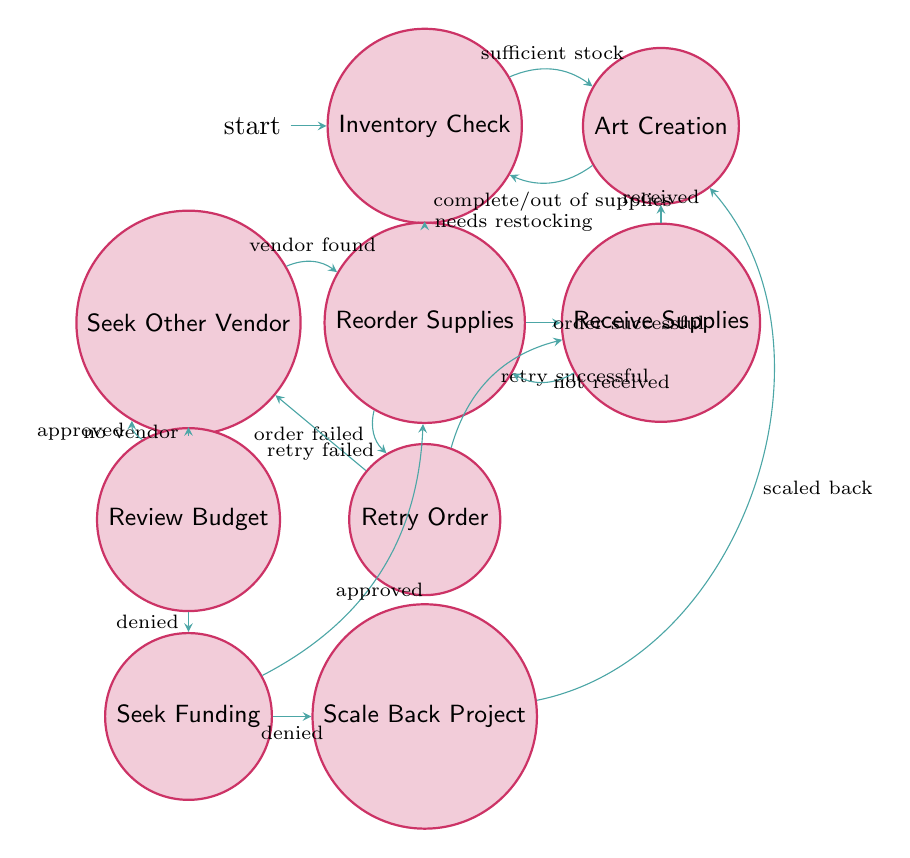What is the initial state of this Finite State Machine? The initial state is represented in the diagram by the starting point, which is labeled "Inventory Check."
Answer: Inventory Check How many states are there in total? To find the total number of states, I count each unique state node in the diagram. There are 10 distinct states: Inventory Check, Art Creation, Reorder Supplies, Receive Supplies, Retry Order, Seek Other Vendor, Review Budget, Seek Funding, Scale Back Project, and Record Broken Supply.
Answer: 10 Which state follows "Receive Supplies" when supplies are received? Following the "Receive Supplies" state, if the supplies are received, the transition leads directly to "Art Creation."
Answer: Art Creation What happens if an order for supplies fails? In the event of a failed order for supplies, the transition takes the flow to the "Retry Order" state.
Answer: Retry Order If the budget review is denied, which state do we proceed to? If the review of the budget is denied, the next state to transition to is "Seek Funding."
Answer: Seek Funding What transition exists between "Retry Order" and "Seek Other Vendor"? The transition from "Retry Order" to "Seek Other Vendor" occurs if the retry of the order fails.
Answer: retry failed What action occurs after "Stock Supplies" if there are stocking issues? If there are issues during the stocking of supplies, the transition takes us to the "Record Broken Supply" state.
Answer: Record Broken Supply How many transitions lead out from the "Art Creation" state? From "Art Creation," there are two transitions leading out: one for completing an art piece and another for running out of supplies.
Answer: 2 What state represents the process of ordering necessary art supplies? The process of ordering necessary art supplies is represented by the "Reorder Supplies" state in the diagram.
Answer: Reorder Supplies What do we do if we cannot find another vendor after seeking one? If no vendor is found after seeking one, the next transition takes us to the "Review Budget" state.
Answer: Review Budget 